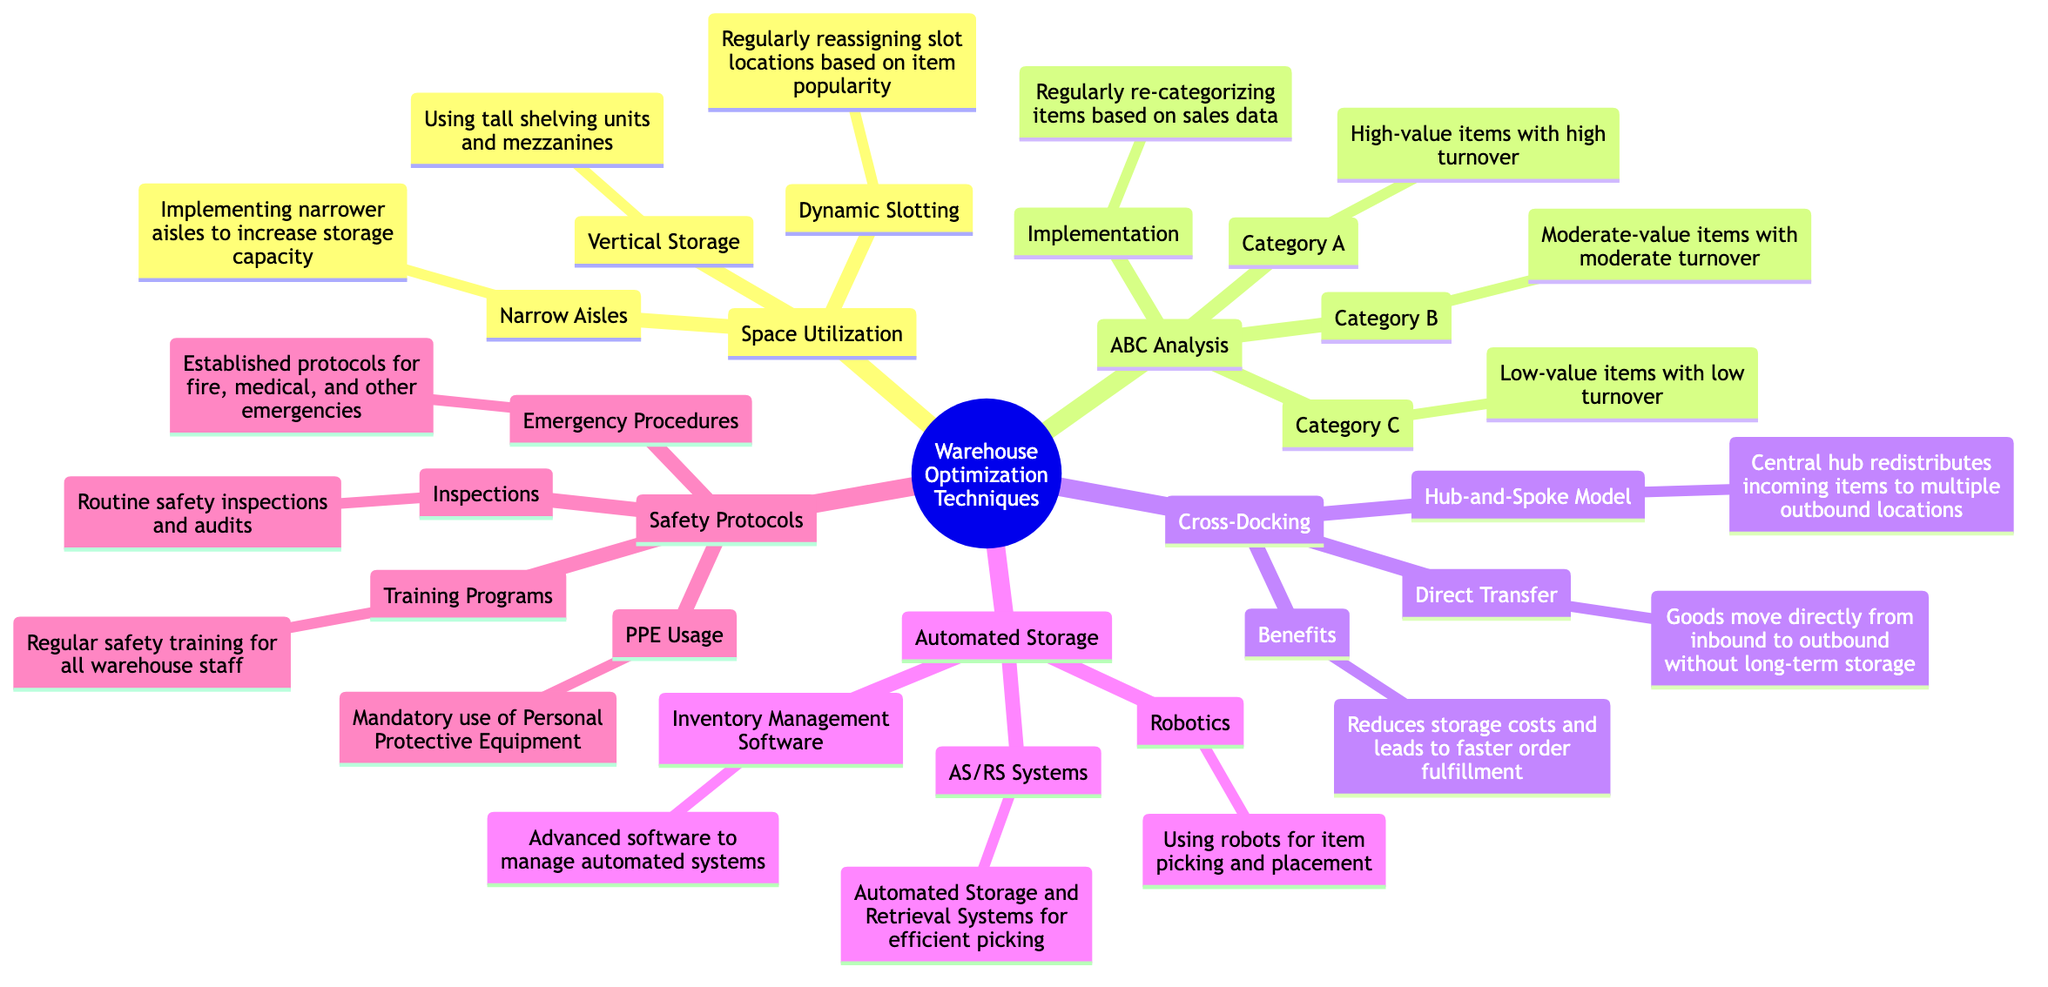What are the three categories in ABC Analysis? The diagram specifies three categories under ABC Analysis: Category A, Category B, and Category C.
Answer: Category A, Category B, Category C What is an example of Vertical Storage? The diagram describes Vertical Storage as using tall shelving units and mezzanines, which fits the definition of that node directly.
Answer: Using tall shelving units and mezzanines What benefits does Cross-Docking provide? According to the diagram, Cross-Docking benefits include reducing storage costs and leading to faster order fulfillment, which are stated clearly under the Cross-Docking node.
Answer: Reduces storage costs and leads to faster order fulfillment How does Dynamic Slotting optimize warehouse space? Dynamic Slotting is described as regularly reassigning slot locations based on item popularity, which implies increases in efficiency and space optimization based on demand.
Answer: Regularly reassigning slot locations based on item popularity What type of systems are included under Automated Storage? The Automated Storage section mentions three specific types: AS/RS Systems, Robotics, and Inventory Management Software, thus directly indicating the types involved in that node.
Answer: AS/RS Systems, Robotics, Inventory Management Software Which category contains high-value items? The diagram specifies that Category A includes high-value items with high turnover, which indicates the type of items classified in this category.
Answer: Category A What is implemented to increase storage capacity through aisle management? Narrow Aisles are mentioned in the diagram as the means to implement narrower aisles to increase storage capacity. Thus, it defines the approach taken.
Answer: Implementing narrower aisles to increase storage capacity What must be used as part of the Safety Protocols? The diagram lists PPE Usage as a mandatory requirement, reflecting a key component of the safety protocols instituted in warehouses.
Answer: Mandatory use of Personal Protective Equipment What is the main function of the Hub-and-Spoke Model? The diagram details the Hub-and-Spoke Model as a method where a central hub redistributes incoming items to multiple outbound locations, thus clarifying its primary function.
Answer: Central hub redistributes incoming items to multiple outbound locations 